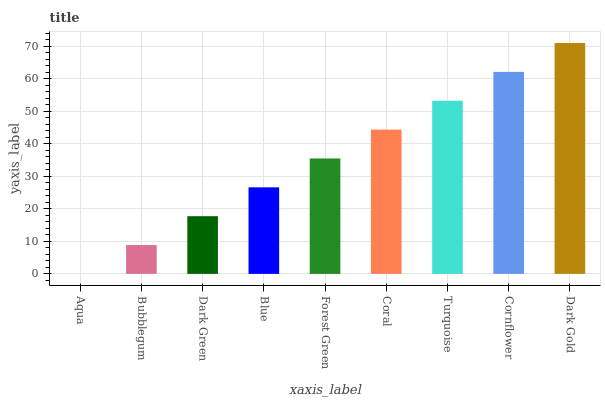Is Aqua the minimum?
Answer yes or no. Yes. Is Dark Gold the maximum?
Answer yes or no. Yes. Is Bubblegum the minimum?
Answer yes or no. No. Is Bubblegum the maximum?
Answer yes or no. No. Is Bubblegum greater than Aqua?
Answer yes or no. Yes. Is Aqua less than Bubblegum?
Answer yes or no. Yes. Is Aqua greater than Bubblegum?
Answer yes or no. No. Is Bubblegum less than Aqua?
Answer yes or no. No. Is Forest Green the high median?
Answer yes or no. Yes. Is Forest Green the low median?
Answer yes or no. Yes. Is Bubblegum the high median?
Answer yes or no. No. Is Aqua the low median?
Answer yes or no. No. 